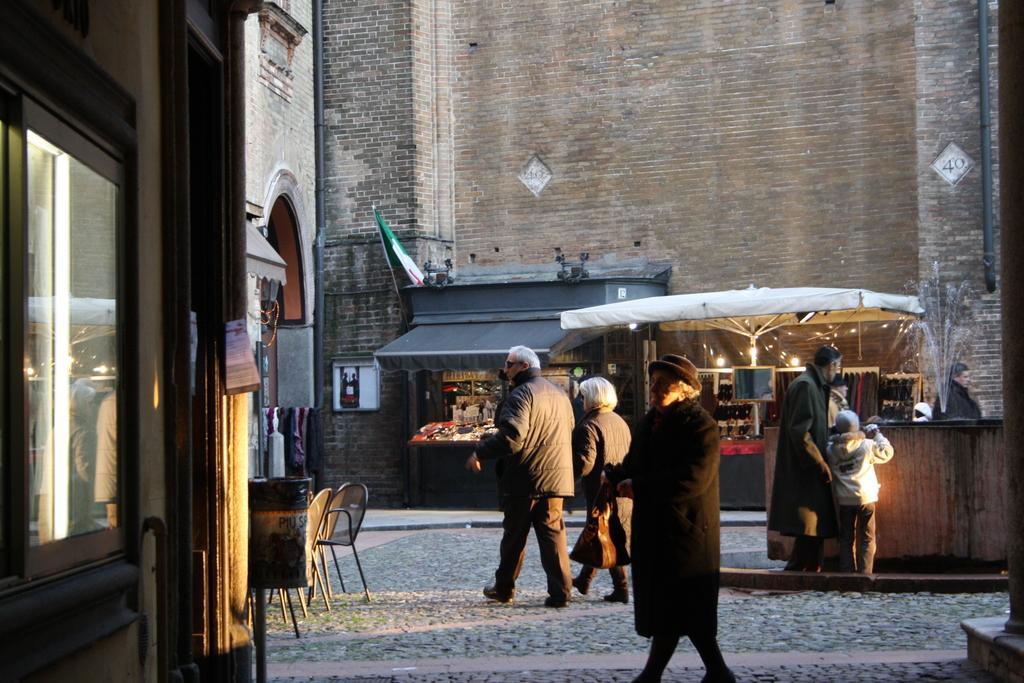Describe this image in one or two sentences. In the picture we can see a path to it, we can see some people are walking and near to it, we can see a building with shop and near it, we can see some chairs and to the opposite side we can see a shop and behind it we can see a building wall. 